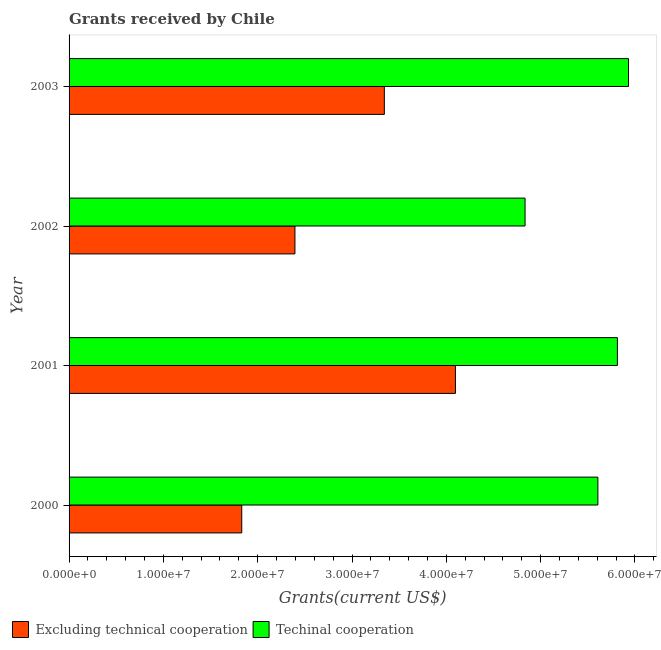How many groups of bars are there?
Ensure brevity in your answer.  4. Are the number of bars per tick equal to the number of legend labels?
Keep it short and to the point. Yes. How many bars are there on the 3rd tick from the bottom?
Provide a succinct answer. 2. What is the label of the 3rd group of bars from the top?
Offer a very short reply. 2001. What is the amount of grants received(including technical cooperation) in 2000?
Offer a very short reply. 5.61e+07. Across all years, what is the maximum amount of grants received(including technical cooperation)?
Provide a succinct answer. 5.93e+07. Across all years, what is the minimum amount of grants received(excluding technical cooperation)?
Offer a terse response. 1.83e+07. In which year was the amount of grants received(including technical cooperation) maximum?
Give a very brief answer. 2003. What is the total amount of grants received(excluding technical cooperation) in the graph?
Give a very brief answer. 1.17e+08. What is the difference between the amount of grants received(including technical cooperation) in 2001 and that in 2003?
Offer a terse response. -1.18e+06. What is the difference between the amount of grants received(excluding technical cooperation) in 2000 and the amount of grants received(including technical cooperation) in 2003?
Your answer should be very brief. -4.10e+07. What is the average amount of grants received(excluding technical cooperation) per year?
Provide a succinct answer. 2.92e+07. In the year 2002, what is the difference between the amount of grants received(excluding technical cooperation) and amount of grants received(including technical cooperation)?
Give a very brief answer. -2.44e+07. What is the ratio of the amount of grants received(excluding technical cooperation) in 2000 to that in 2001?
Provide a succinct answer. 0.45. Is the difference between the amount of grants received(excluding technical cooperation) in 2001 and 2003 greater than the difference between the amount of grants received(including technical cooperation) in 2001 and 2003?
Offer a very short reply. Yes. What is the difference between the highest and the second highest amount of grants received(excluding technical cooperation)?
Make the answer very short. 7.54e+06. What is the difference between the highest and the lowest amount of grants received(excluding technical cooperation)?
Ensure brevity in your answer.  2.27e+07. In how many years, is the amount of grants received(excluding technical cooperation) greater than the average amount of grants received(excluding technical cooperation) taken over all years?
Provide a short and direct response. 2. Is the sum of the amount of grants received(including technical cooperation) in 2000 and 2001 greater than the maximum amount of grants received(excluding technical cooperation) across all years?
Your answer should be very brief. Yes. What does the 2nd bar from the top in 2003 represents?
Your answer should be compact. Excluding technical cooperation. What does the 1st bar from the bottom in 2003 represents?
Make the answer very short. Excluding technical cooperation. How many bars are there?
Offer a very short reply. 8. Does the graph contain any zero values?
Your response must be concise. No. Does the graph contain grids?
Make the answer very short. No. How many legend labels are there?
Give a very brief answer. 2. How are the legend labels stacked?
Give a very brief answer. Horizontal. What is the title of the graph?
Offer a very short reply. Grants received by Chile. What is the label or title of the X-axis?
Your answer should be compact. Grants(current US$). What is the label or title of the Y-axis?
Keep it short and to the point. Year. What is the Grants(current US$) in Excluding technical cooperation in 2000?
Your answer should be very brief. 1.83e+07. What is the Grants(current US$) of Techinal cooperation in 2000?
Your answer should be very brief. 5.61e+07. What is the Grants(current US$) of Excluding technical cooperation in 2001?
Your response must be concise. 4.10e+07. What is the Grants(current US$) in Techinal cooperation in 2001?
Your answer should be very brief. 5.81e+07. What is the Grants(current US$) in Excluding technical cooperation in 2002?
Ensure brevity in your answer.  2.40e+07. What is the Grants(current US$) in Techinal cooperation in 2002?
Your response must be concise. 4.84e+07. What is the Grants(current US$) in Excluding technical cooperation in 2003?
Provide a short and direct response. 3.34e+07. What is the Grants(current US$) of Techinal cooperation in 2003?
Your response must be concise. 5.93e+07. Across all years, what is the maximum Grants(current US$) of Excluding technical cooperation?
Ensure brevity in your answer.  4.10e+07. Across all years, what is the maximum Grants(current US$) in Techinal cooperation?
Your answer should be very brief. 5.93e+07. Across all years, what is the minimum Grants(current US$) of Excluding technical cooperation?
Your response must be concise. 1.83e+07. Across all years, what is the minimum Grants(current US$) of Techinal cooperation?
Your answer should be very brief. 4.84e+07. What is the total Grants(current US$) of Excluding technical cooperation in the graph?
Offer a terse response. 1.17e+08. What is the total Grants(current US$) in Techinal cooperation in the graph?
Provide a short and direct response. 2.22e+08. What is the difference between the Grants(current US$) in Excluding technical cooperation in 2000 and that in 2001?
Your answer should be very brief. -2.27e+07. What is the difference between the Grants(current US$) of Techinal cooperation in 2000 and that in 2001?
Make the answer very short. -2.07e+06. What is the difference between the Grants(current US$) in Excluding technical cooperation in 2000 and that in 2002?
Offer a very short reply. -5.64e+06. What is the difference between the Grants(current US$) of Techinal cooperation in 2000 and that in 2002?
Your response must be concise. 7.72e+06. What is the difference between the Grants(current US$) in Excluding technical cooperation in 2000 and that in 2003?
Ensure brevity in your answer.  -1.51e+07. What is the difference between the Grants(current US$) of Techinal cooperation in 2000 and that in 2003?
Keep it short and to the point. -3.25e+06. What is the difference between the Grants(current US$) in Excluding technical cooperation in 2001 and that in 2002?
Keep it short and to the point. 1.70e+07. What is the difference between the Grants(current US$) of Techinal cooperation in 2001 and that in 2002?
Your answer should be compact. 9.79e+06. What is the difference between the Grants(current US$) in Excluding technical cooperation in 2001 and that in 2003?
Keep it short and to the point. 7.54e+06. What is the difference between the Grants(current US$) of Techinal cooperation in 2001 and that in 2003?
Make the answer very short. -1.18e+06. What is the difference between the Grants(current US$) in Excluding technical cooperation in 2002 and that in 2003?
Ensure brevity in your answer.  -9.48e+06. What is the difference between the Grants(current US$) of Techinal cooperation in 2002 and that in 2003?
Make the answer very short. -1.10e+07. What is the difference between the Grants(current US$) in Excluding technical cooperation in 2000 and the Grants(current US$) in Techinal cooperation in 2001?
Give a very brief answer. -3.98e+07. What is the difference between the Grants(current US$) of Excluding technical cooperation in 2000 and the Grants(current US$) of Techinal cooperation in 2002?
Offer a terse response. -3.00e+07. What is the difference between the Grants(current US$) in Excluding technical cooperation in 2000 and the Grants(current US$) in Techinal cooperation in 2003?
Provide a succinct answer. -4.10e+07. What is the difference between the Grants(current US$) in Excluding technical cooperation in 2001 and the Grants(current US$) in Techinal cooperation in 2002?
Your answer should be compact. -7.38e+06. What is the difference between the Grants(current US$) in Excluding technical cooperation in 2001 and the Grants(current US$) in Techinal cooperation in 2003?
Your answer should be compact. -1.84e+07. What is the difference between the Grants(current US$) in Excluding technical cooperation in 2002 and the Grants(current US$) in Techinal cooperation in 2003?
Provide a short and direct response. -3.54e+07. What is the average Grants(current US$) of Excluding technical cooperation per year?
Provide a succinct answer. 2.92e+07. What is the average Grants(current US$) of Techinal cooperation per year?
Offer a very short reply. 5.55e+07. In the year 2000, what is the difference between the Grants(current US$) in Excluding technical cooperation and Grants(current US$) in Techinal cooperation?
Offer a terse response. -3.78e+07. In the year 2001, what is the difference between the Grants(current US$) of Excluding technical cooperation and Grants(current US$) of Techinal cooperation?
Your answer should be very brief. -1.72e+07. In the year 2002, what is the difference between the Grants(current US$) of Excluding technical cooperation and Grants(current US$) of Techinal cooperation?
Provide a succinct answer. -2.44e+07. In the year 2003, what is the difference between the Grants(current US$) of Excluding technical cooperation and Grants(current US$) of Techinal cooperation?
Offer a terse response. -2.59e+07. What is the ratio of the Grants(current US$) of Excluding technical cooperation in 2000 to that in 2001?
Keep it short and to the point. 0.45. What is the ratio of the Grants(current US$) of Techinal cooperation in 2000 to that in 2001?
Your response must be concise. 0.96. What is the ratio of the Grants(current US$) in Excluding technical cooperation in 2000 to that in 2002?
Provide a short and direct response. 0.76. What is the ratio of the Grants(current US$) of Techinal cooperation in 2000 to that in 2002?
Your response must be concise. 1.16. What is the ratio of the Grants(current US$) in Excluding technical cooperation in 2000 to that in 2003?
Provide a short and direct response. 0.55. What is the ratio of the Grants(current US$) of Techinal cooperation in 2000 to that in 2003?
Provide a short and direct response. 0.95. What is the ratio of the Grants(current US$) of Excluding technical cooperation in 2001 to that in 2002?
Your answer should be very brief. 1.71. What is the ratio of the Grants(current US$) of Techinal cooperation in 2001 to that in 2002?
Offer a terse response. 1.2. What is the ratio of the Grants(current US$) in Excluding technical cooperation in 2001 to that in 2003?
Your answer should be very brief. 1.23. What is the ratio of the Grants(current US$) in Techinal cooperation in 2001 to that in 2003?
Offer a very short reply. 0.98. What is the ratio of the Grants(current US$) of Excluding technical cooperation in 2002 to that in 2003?
Provide a succinct answer. 0.72. What is the ratio of the Grants(current US$) of Techinal cooperation in 2002 to that in 2003?
Make the answer very short. 0.82. What is the difference between the highest and the second highest Grants(current US$) in Excluding technical cooperation?
Your answer should be very brief. 7.54e+06. What is the difference between the highest and the second highest Grants(current US$) of Techinal cooperation?
Provide a succinct answer. 1.18e+06. What is the difference between the highest and the lowest Grants(current US$) in Excluding technical cooperation?
Provide a succinct answer. 2.27e+07. What is the difference between the highest and the lowest Grants(current US$) of Techinal cooperation?
Provide a short and direct response. 1.10e+07. 